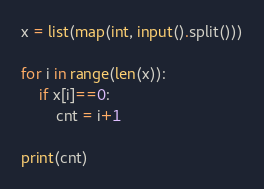<code> <loc_0><loc_0><loc_500><loc_500><_Python_>x = list(map(int, input().split()))

for i in range(len(x)):
    if x[i]==0:
        cnt = i+1

print(cnt)</code> 